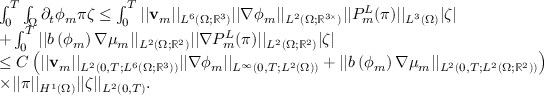<formula> <loc_0><loc_0><loc_500><loc_500>\begin{array} { r l } & { \int _ { 0 } ^ { T } \int _ { \Omega } \partial _ { t } \phi _ { m } \pi \zeta \leq \int _ { 0 } ^ { T } | | v _ { m } | | _ { L ^ { 6 } ( \Omega ; \mathbb { R } ^ { 3 } ) } | | \nabla \phi _ { m } | | _ { L ^ { 2 } ( \Omega ; \mathbb { R } ^ { 3 \times } ) } | | P _ { m } ^ { L } ( \pi ) | | _ { L ^ { 3 } ( \Omega ) } | \zeta | } \\ & { + \int _ { 0 } ^ { T } | | b \left ( \phi _ { m } \right ) \nabla \mu _ { m } | | _ { L ^ { 2 } ( \Omega ; \mathbb { R } ^ { 2 } ) } | | \nabla P _ { m } ^ { L } ( \pi ) | | _ { L ^ { 2 } ( \Omega ; \mathbb { R } ^ { 2 } ) } | \zeta | } \\ & { \leq C \left ( | | v _ { m } | | _ { L ^ { 2 } ( 0 , T ; L ^ { 6 } ( \Omega ; \mathbb { R } ^ { 3 } ) ) } | | \nabla \phi _ { m } | | _ { L ^ { \infty } ( 0 , T ; L ^ { 2 } ( \Omega ) ) } + | | b \left ( \phi _ { m } \right ) \nabla \mu _ { m } | | _ { L ^ { 2 } ( 0 , T ; L ^ { 2 } ( \Omega ; \mathbb { R } ^ { 2 } ) ) } \right ) } \\ & { \times | | \pi | | _ { H ^ { 1 } ( \Omega ) } | | \zeta | | _ { L ^ { 2 } ( 0 , T ) } . } \end{array}</formula> 